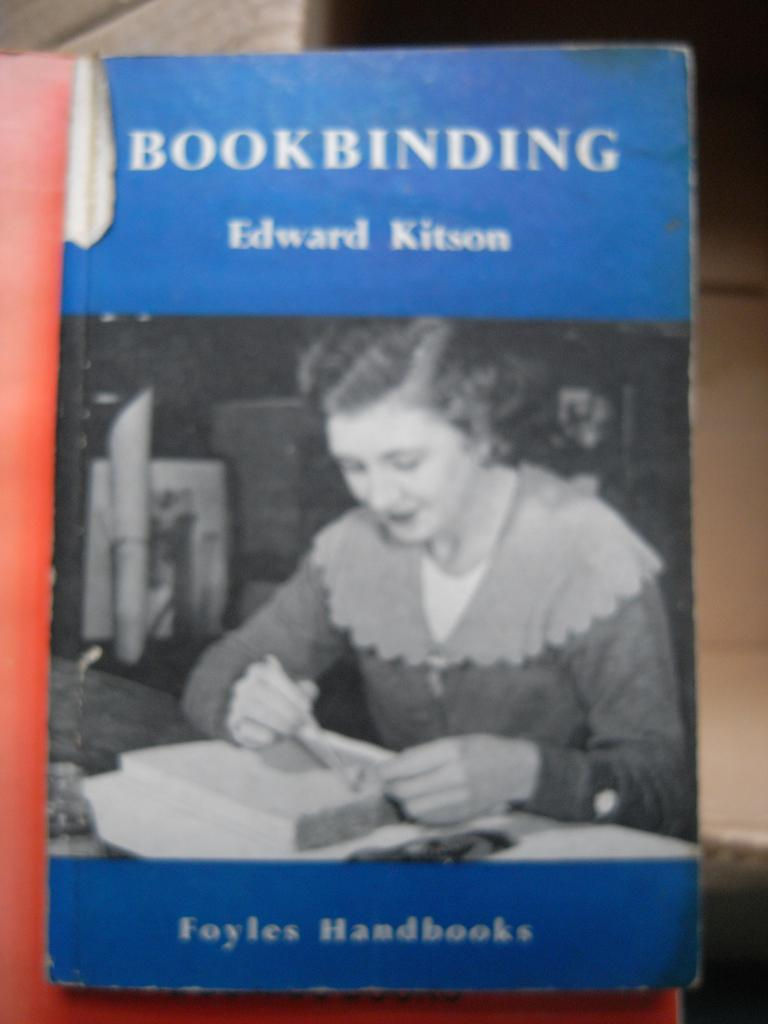<image>
Give a short and clear explanation of the subsequent image. The book shown is an old book about bookbinding. 